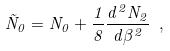Convert formula to latex. <formula><loc_0><loc_0><loc_500><loc_500>\tilde { N } _ { 0 } = N _ { 0 } + \frac { 1 } { 8 } \frac { d ^ { 2 } N _ { 2 } } { d \beta ^ { 2 } } \ ,</formula> 